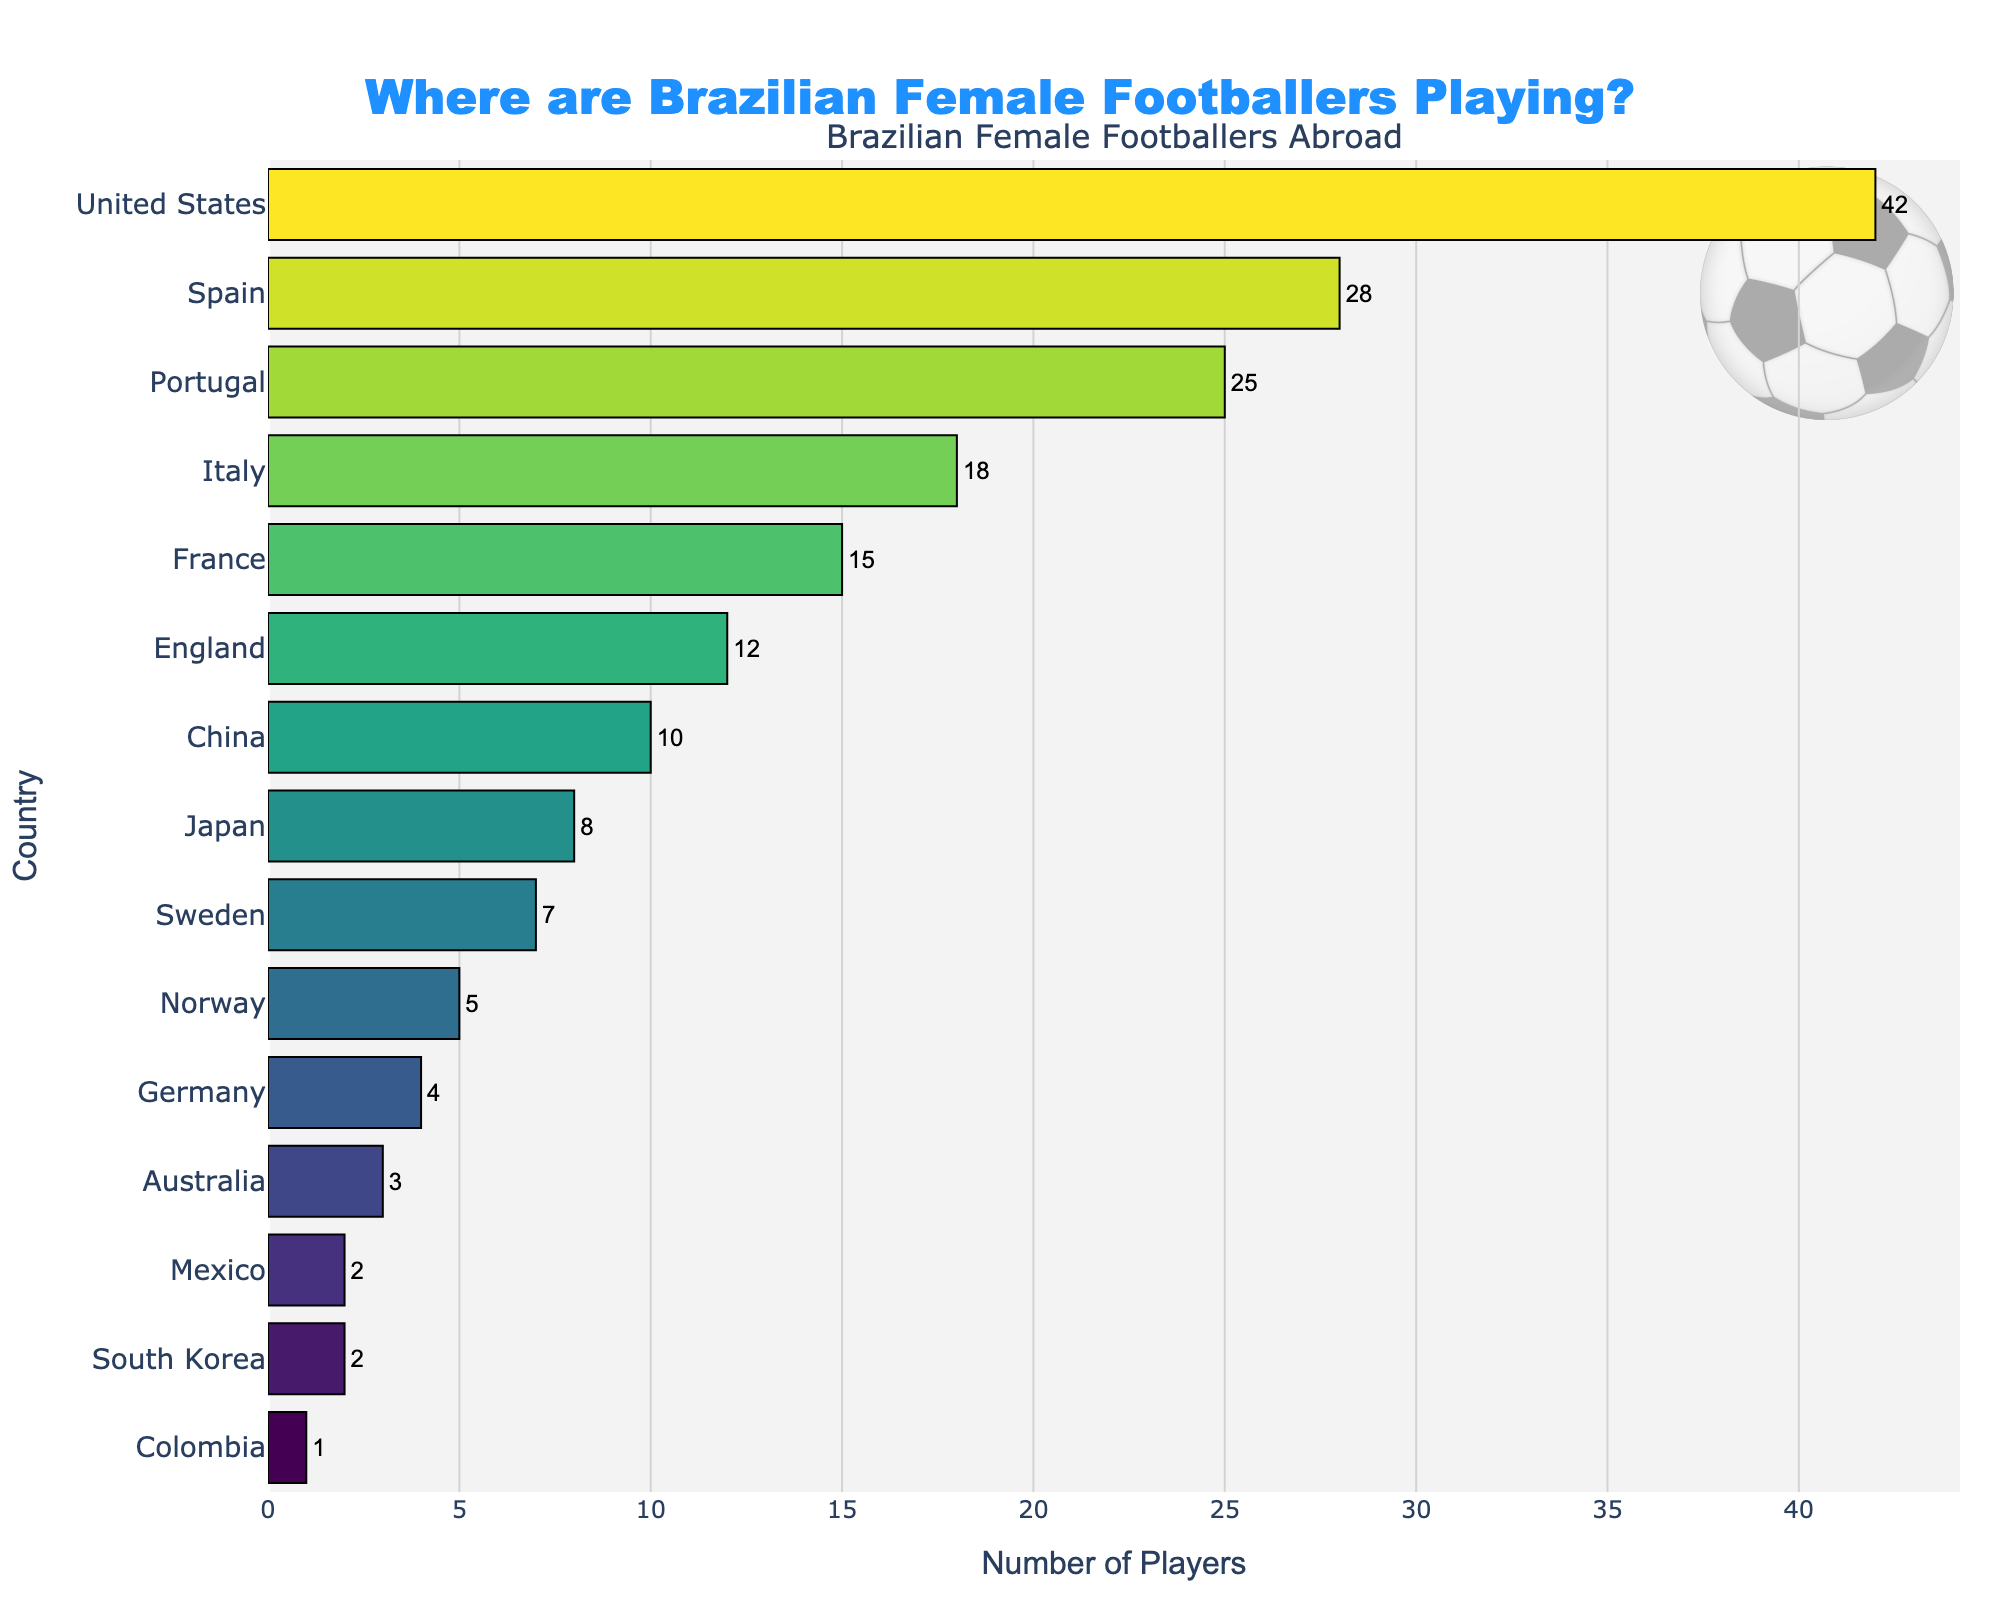What is the total number of Brazilian female footballers playing in Spain and Portugal? Add the number of players in Spain (28) and Portugal (25): 28 + 25 = 53
Answer: 53 Which country has more Brazilian female footballers, France or Italy? Compare the number of players in France (15) and Italy (18). Italy has more players.
Answer: Italy How many more Brazilian female footballers play in the United States compared to Japan? Subtract the number of players in Japan (8) from the number in the United States (42): 42 - 8 = 34
Answer: 34 Which two countries have the fewest Brazilian female footballers, and how do their numbers compare? Identify the countries with the lowest players: Colombia (1) and South Korea (2). Colombia has 1 less player than South Korea.
Answer: Colombia, South Korea What is the combined number of players in the top three countries? Add the number of players in the United States (42), Spain (28), and Portugal (25): 42 + 28 + 25 = 95
Answer: 95 Which country has more Brazilian female footballers: Sweden or China? Compare the number of players in Sweden (7) and China (10). China has more players.
Answer: China What percentage of the total players are playing in England? The total number of players is 42+28+25+18+15+12+10+8+7+5+4+3+2+2+1 = 182. The number of players in England is 12. Calculate the percentage: (12/182) * 100 ≈ 6.59%
Answer: 6.59% How many countries have fewer than 10 Brazilian female footballers? By counting, the countries are: Germany, Australia, South Korea, Mexico, Colombia, Japan, Sweden, and Norway (8 countries).
Answer: 8 What is the difference in the number of players between the country with the most and the country with the least Brazilian female footballers? Subtract the number of players in Colombia (1) from the number in the United States (42): 42 - 1 = 41
Answer: 41 Which country has almost double the number of Brazilian female footballers compared to Norway? Norway has 5 players. The country with almost double is Japan with 8 players.
Answer: Japan 